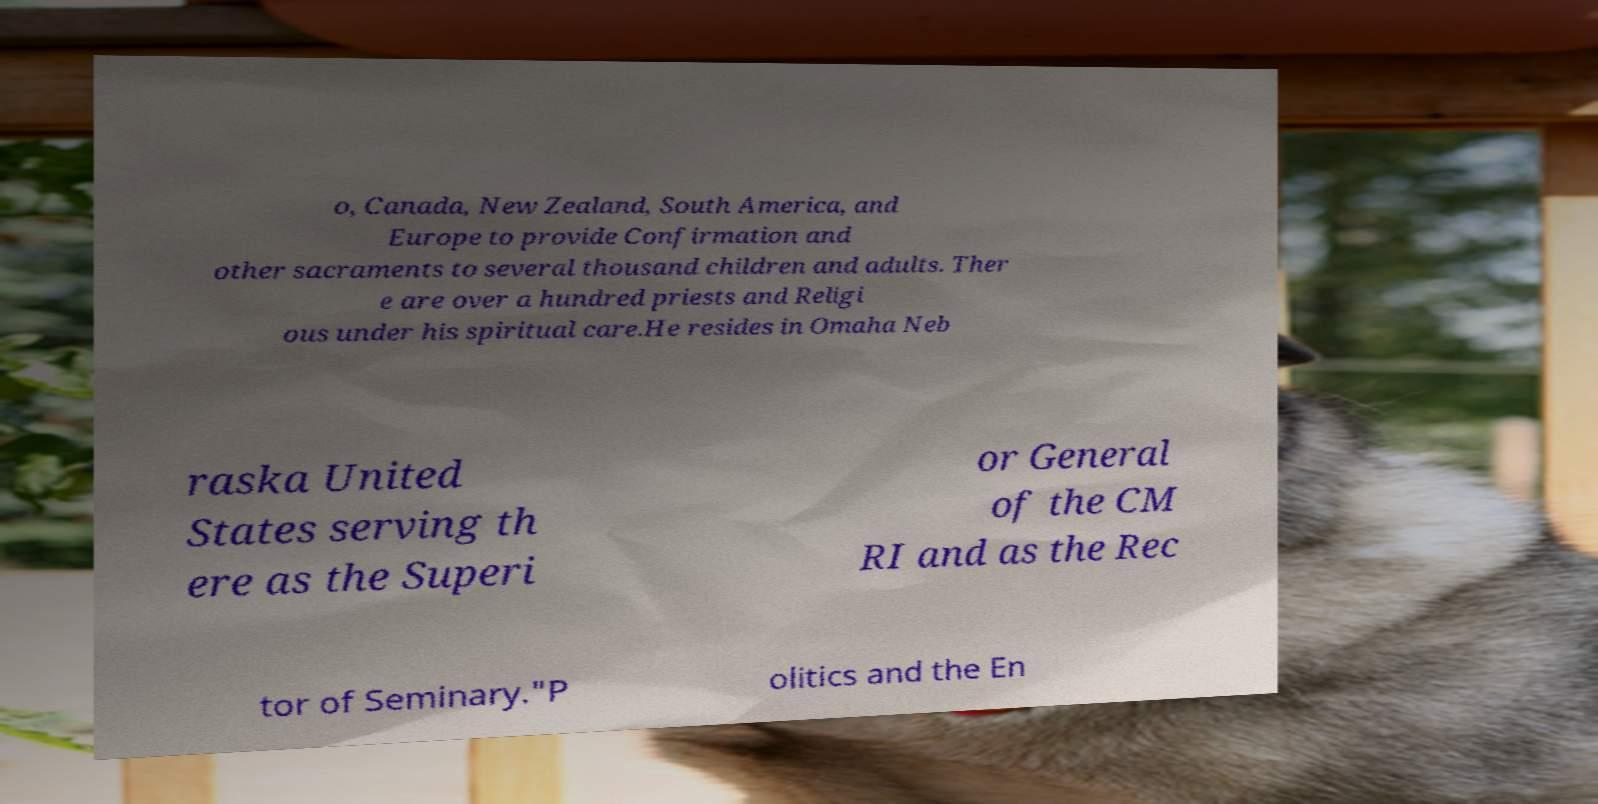Can you accurately transcribe the text from the provided image for me? o, Canada, New Zealand, South America, and Europe to provide Confirmation and other sacraments to several thousand children and adults. Ther e are over a hundred priests and Religi ous under his spiritual care.He resides in Omaha Neb raska United States serving th ere as the Superi or General of the CM RI and as the Rec tor of Seminary."P olitics and the En 